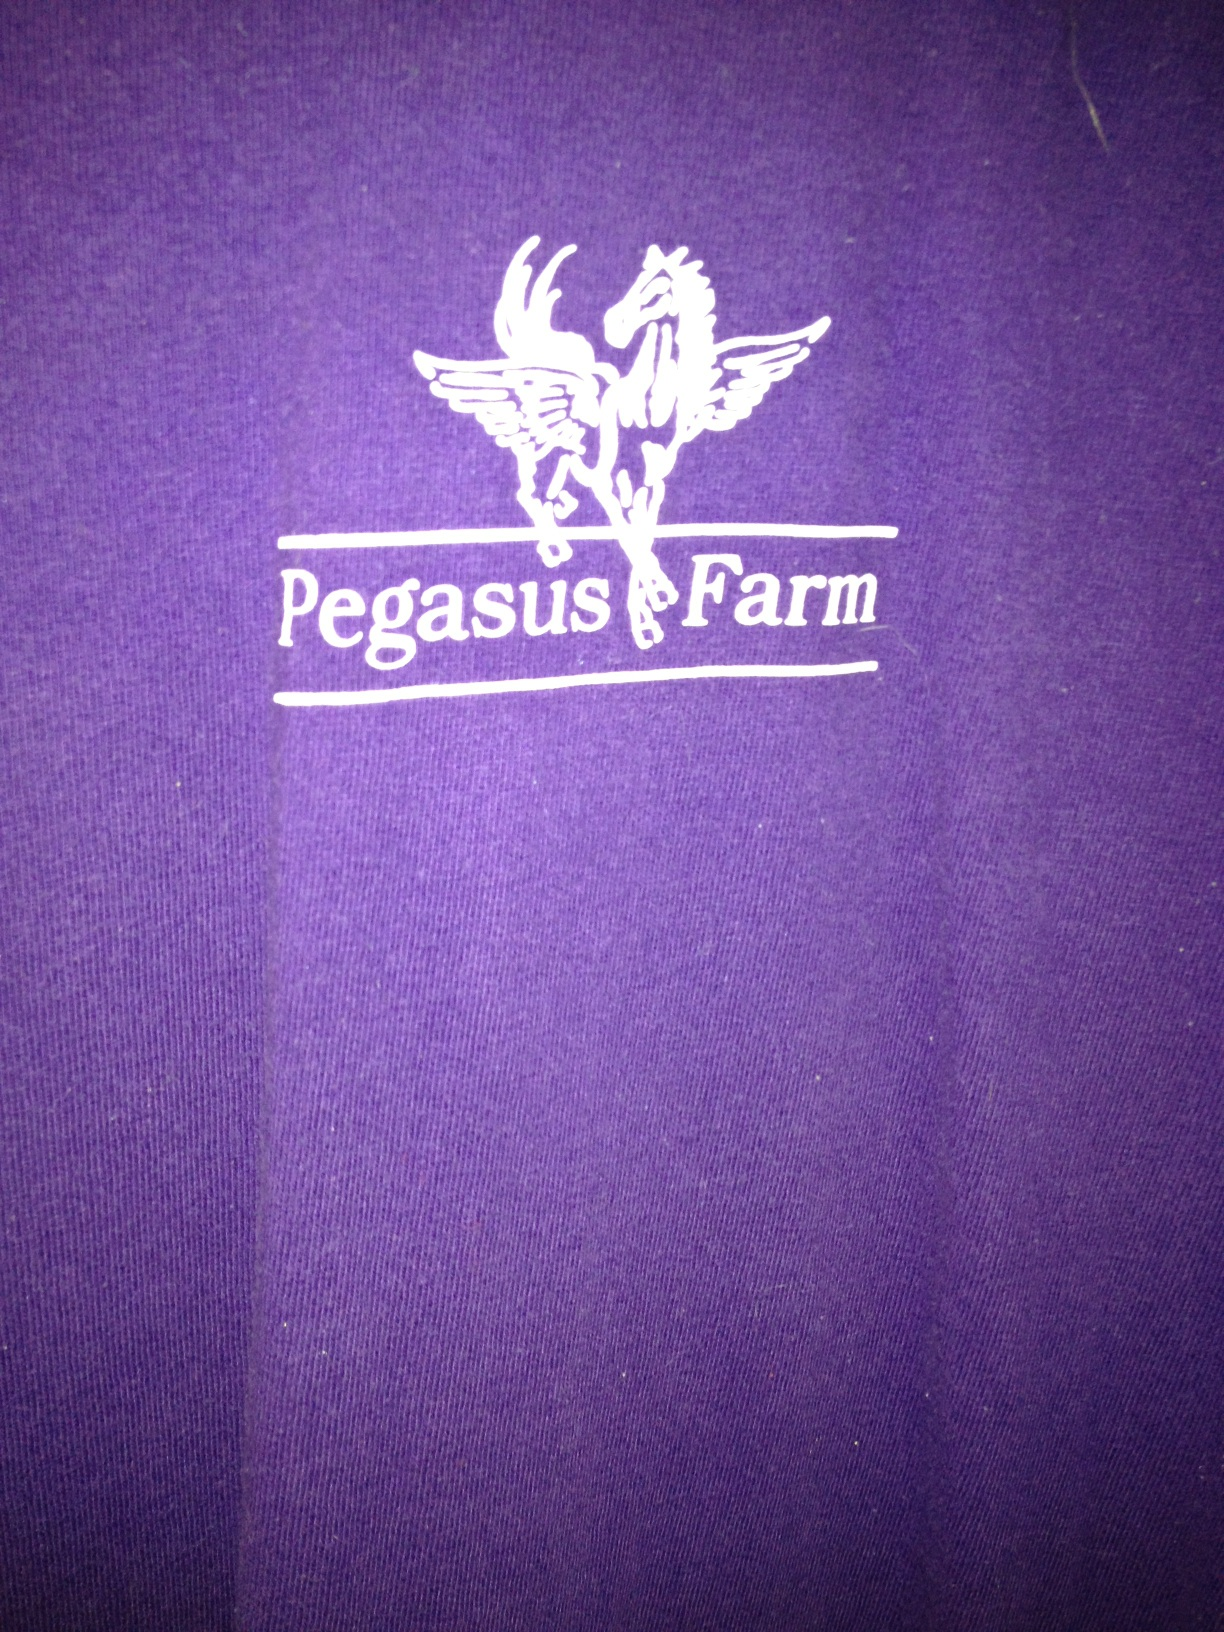Can you please tell me what color my shirt is?  THank you. from Vizwiz purple 